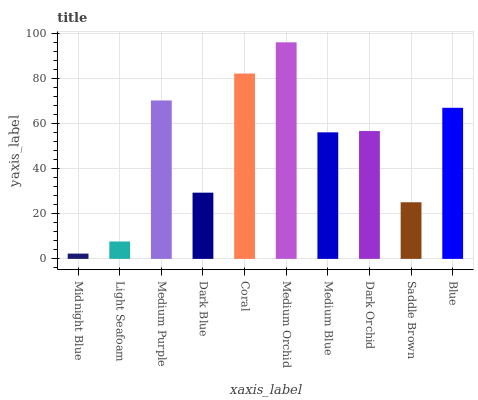Is Midnight Blue the minimum?
Answer yes or no. Yes. Is Medium Orchid the maximum?
Answer yes or no. Yes. Is Light Seafoam the minimum?
Answer yes or no. No. Is Light Seafoam the maximum?
Answer yes or no. No. Is Light Seafoam greater than Midnight Blue?
Answer yes or no. Yes. Is Midnight Blue less than Light Seafoam?
Answer yes or no. Yes. Is Midnight Blue greater than Light Seafoam?
Answer yes or no. No. Is Light Seafoam less than Midnight Blue?
Answer yes or no. No. Is Dark Orchid the high median?
Answer yes or no. Yes. Is Medium Blue the low median?
Answer yes or no. Yes. Is Coral the high median?
Answer yes or no. No. Is Dark Blue the low median?
Answer yes or no. No. 